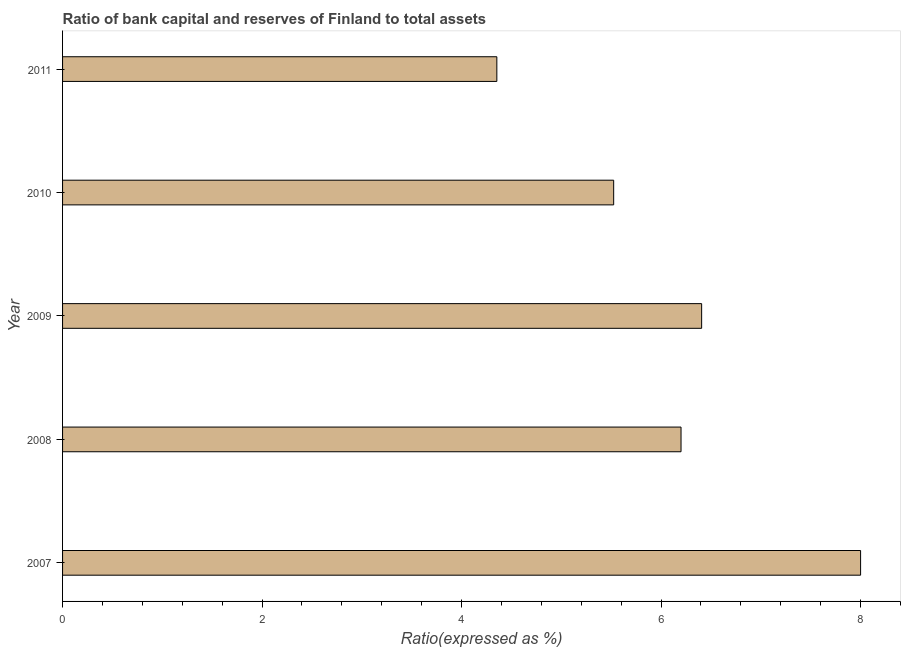Does the graph contain grids?
Your answer should be very brief. No. What is the title of the graph?
Your answer should be very brief. Ratio of bank capital and reserves of Finland to total assets. What is the label or title of the X-axis?
Offer a terse response. Ratio(expressed as %). What is the label or title of the Y-axis?
Your answer should be very brief. Year. What is the bank capital to assets ratio in 2010?
Keep it short and to the point. 5.52. Across all years, what is the maximum bank capital to assets ratio?
Your answer should be compact. 8. Across all years, what is the minimum bank capital to assets ratio?
Make the answer very short. 4.35. In which year was the bank capital to assets ratio maximum?
Keep it short and to the point. 2007. In which year was the bank capital to assets ratio minimum?
Offer a terse response. 2011. What is the sum of the bank capital to assets ratio?
Provide a short and direct response. 30.48. What is the difference between the bank capital to assets ratio in 2008 and 2011?
Provide a succinct answer. 1.85. What is the average bank capital to assets ratio per year?
Provide a succinct answer. 6.1. Do a majority of the years between 2009 and 2010 (inclusive) have bank capital to assets ratio greater than 4.8 %?
Keep it short and to the point. Yes. What is the ratio of the bank capital to assets ratio in 2008 to that in 2010?
Provide a succinct answer. 1.12. Is the difference between the bank capital to assets ratio in 2007 and 2008 greater than the difference between any two years?
Make the answer very short. No. What is the difference between the highest and the second highest bank capital to assets ratio?
Provide a short and direct response. 1.59. Is the sum of the bank capital to assets ratio in 2007 and 2008 greater than the maximum bank capital to assets ratio across all years?
Keep it short and to the point. Yes. What is the difference between the highest and the lowest bank capital to assets ratio?
Make the answer very short. 3.65. In how many years, is the bank capital to assets ratio greater than the average bank capital to assets ratio taken over all years?
Give a very brief answer. 3. How many years are there in the graph?
Your response must be concise. 5. What is the difference between two consecutive major ticks on the X-axis?
Offer a terse response. 2. Are the values on the major ticks of X-axis written in scientific E-notation?
Your response must be concise. No. What is the Ratio(expressed as %) in 2007?
Give a very brief answer. 8. What is the Ratio(expressed as %) of 2009?
Provide a succinct answer. 6.41. What is the Ratio(expressed as %) of 2010?
Offer a very short reply. 5.52. What is the Ratio(expressed as %) in 2011?
Offer a very short reply. 4.35. What is the difference between the Ratio(expressed as %) in 2007 and 2008?
Your answer should be compact. 1.8. What is the difference between the Ratio(expressed as %) in 2007 and 2009?
Keep it short and to the point. 1.59. What is the difference between the Ratio(expressed as %) in 2007 and 2010?
Give a very brief answer. 2.48. What is the difference between the Ratio(expressed as %) in 2007 and 2011?
Provide a succinct answer. 3.65. What is the difference between the Ratio(expressed as %) in 2008 and 2009?
Your response must be concise. -0.21. What is the difference between the Ratio(expressed as %) in 2008 and 2010?
Provide a short and direct response. 0.68. What is the difference between the Ratio(expressed as %) in 2008 and 2011?
Offer a terse response. 1.85. What is the difference between the Ratio(expressed as %) in 2009 and 2010?
Provide a succinct answer. 0.88. What is the difference between the Ratio(expressed as %) in 2009 and 2011?
Provide a short and direct response. 2.05. What is the difference between the Ratio(expressed as %) in 2010 and 2011?
Offer a very short reply. 1.17. What is the ratio of the Ratio(expressed as %) in 2007 to that in 2008?
Offer a very short reply. 1.29. What is the ratio of the Ratio(expressed as %) in 2007 to that in 2009?
Make the answer very short. 1.25. What is the ratio of the Ratio(expressed as %) in 2007 to that in 2010?
Offer a terse response. 1.45. What is the ratio of the Ratio(expressed as %) in 2007 to that in 2011?
Your answer should be very brief. 1.84. What is the ratio of the Ratio(expressed as %) in 2008 to that in 2009?
Your answer should be very brief. 0.97. What is the ratio of the Ratio(expressed as %) in 2008 to that in 2010?
Offer a terse response. 1.12. What is the ratio of the Ratio(expressed as %) in 2008 to that in 2011?
Make the answer very short. 1.42. What is the ratio of the Ratio(expressed as %) in 2009 to that in 2010?
Your answer should be very brief. 1.16. What is the ratio of the Ratio(expressed as %) in 2009 to that in 2011?
Ensure brevity in your answer.  1.47. What is the ratio of the Ratio(expressed as %) in 2010 to that in 2011?
Offer a very short reply. 1.27. 